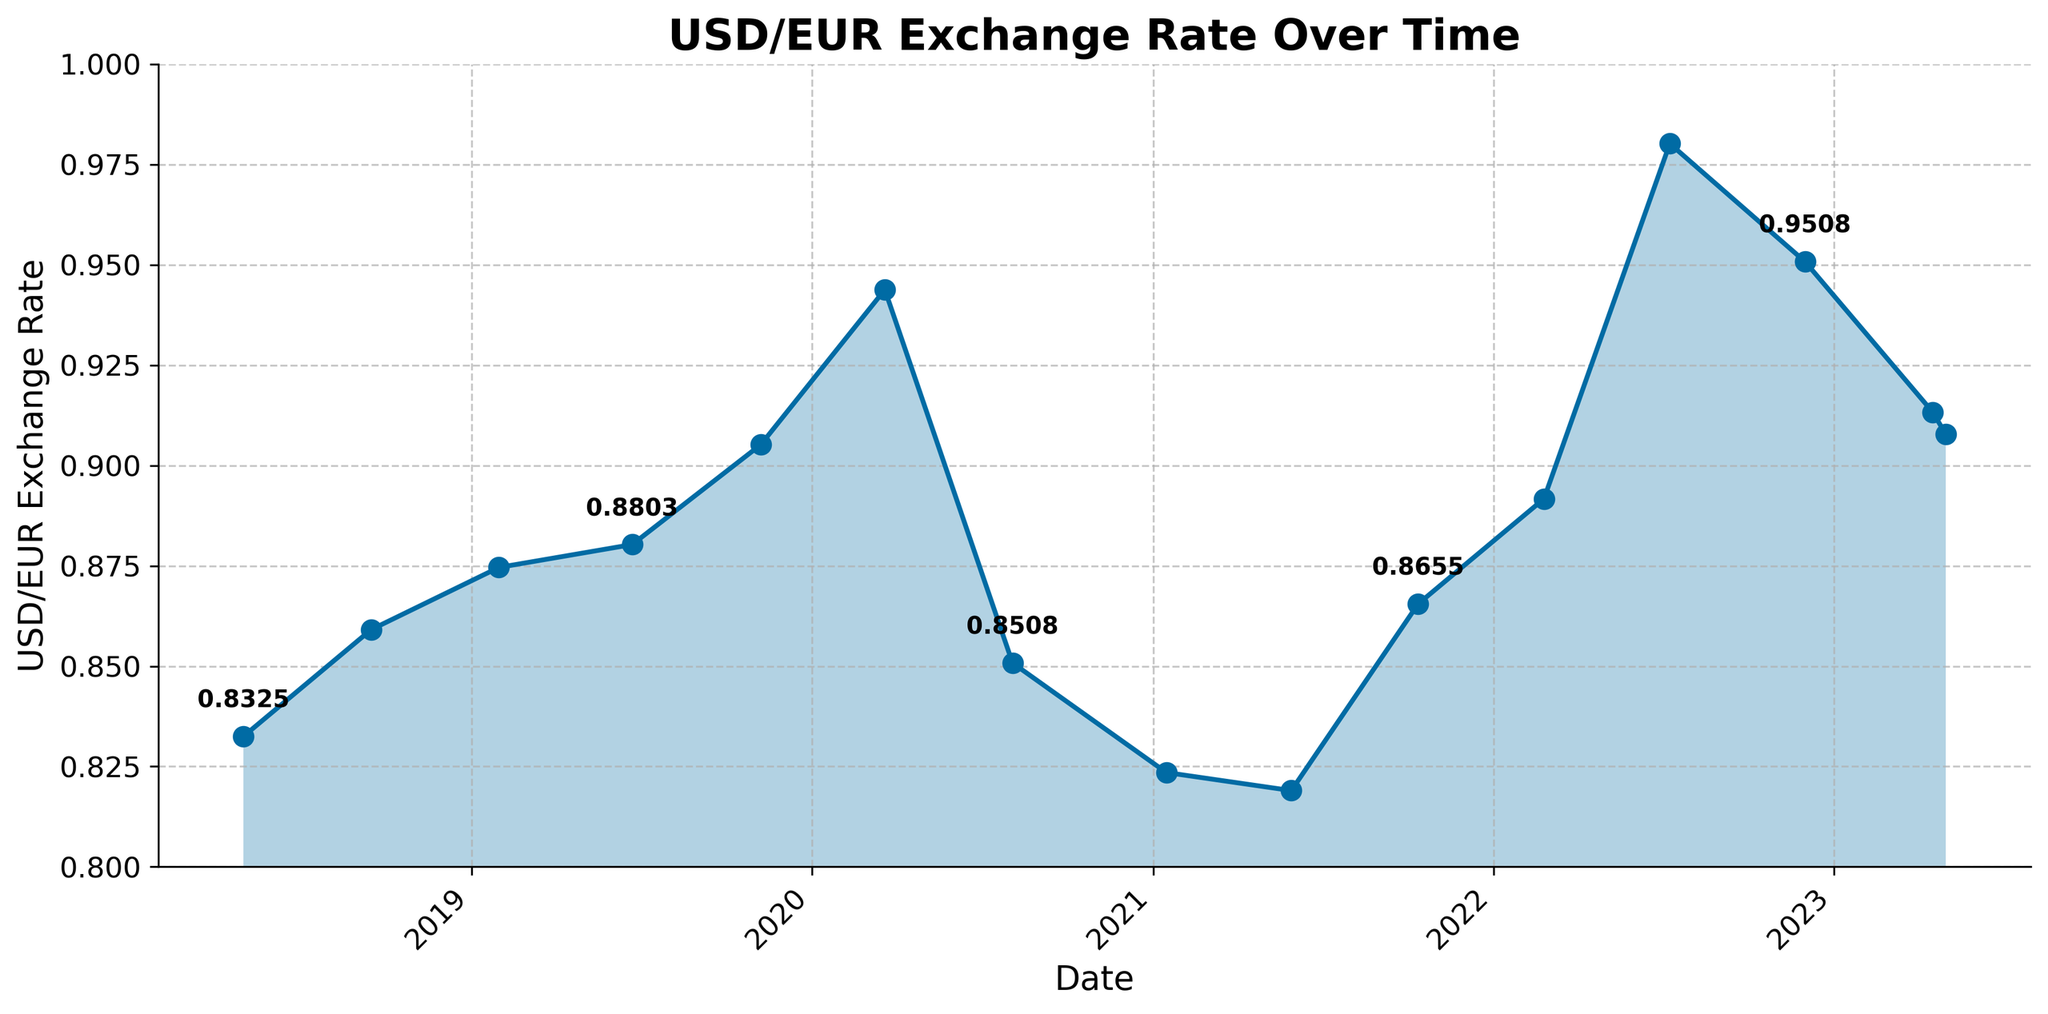What's the highest exchange rate between USD and Euro in the last 5 years? To find the highest exchange rate, look for the highest point on the line chart. The highest rate is around July 2022. The exact value can be checked from the date markers.
Answer: 0.9802 What's the lowest exchange rate between USD and Euro in the last 5 years? To find the lowest exchange rate, look for the lowest point on the line chart. The lowest rate is around May 2018. The exact value can be checked from the date markers.
Answer: 0.8190 What is the average exchange rate between USD and Euro over the shown period? Sum all the exchange rates recorded over the period, then divide by the number of data points. The sum is (0.8325 + 0.8591 + 0.8746 + 0.8803 + 0.9052 + 0.9438 + 0.8508 + 0.8235 + 0.8190 + 0.8655 + 0.8917 + 0.9802 + 0.9508 + 0.9133 + 0.9078) = 13.2971, and there are 15 data points, so the average rate is 13.2971 / 15.
Answer: 0.8865 Between which two dates did the exchange rate fluctuate the most? Check the steepest sections of the line chart to find where the most significant changes occurred. The largest fluctuation appears between March 2020 and August 2020, where the rate decreased sharply.
Answer: March 2020 and August 2020 What's the trend of the USD/EUR exchange rate in 2022? Observe the direction of the line for 2022. The rate first increases from February 2022 until July 2022 and decreases towards the end of the year. This indicates an initial upward trend followed by a downward trend.
Answer: Upward then downward In which period does the USD/EUR exchange rate experience the most stability? Look for the flattest part of the line chart where the rate remains almost constant. The exchange rate appears most stable from around May 2021 to October 2021.
Answer: May 2021 to October 2021 How did the exchange rate change from February 2022 to July 2022? Locate February 2022 and July 2022 on the x-axis, then observe how the line moves between these points. The line steeply rises, showing an increase in the exchange rate.
Answer: Increased What was the exchange rate in January 2021? Locate January 2021 on the x-axis and find the corresponding point on the line chart. The rate in January 2021 is marked as 0.8235.
Answer: 0.8235 Is the exchange rate higher or lower in April 2023 compared to November 2019? First, find both dates on the x-axis and then compare their positions on the y-axis. April 2023 has a rate of 0.9133, which is higher than the 0.9052 recorded in November 2019.
Answer: Higher What is the percentage change in exchange rate from January 2021 (0.8235) to July 2022 (0.9802)? The change in value is 0.9802 - 0.8235 = 0.1567. To find the percentage change, divide the change by the old value (0.8235) and multiply by 100. Percentage change = (0.1567 / 0.8235) * 100 ≈ 19.03%.
Answer: 19.03% 